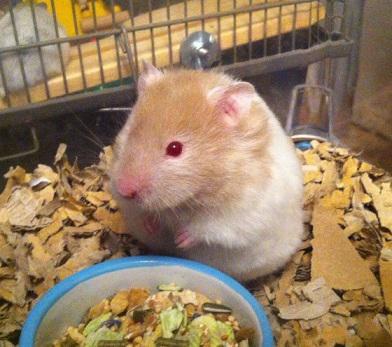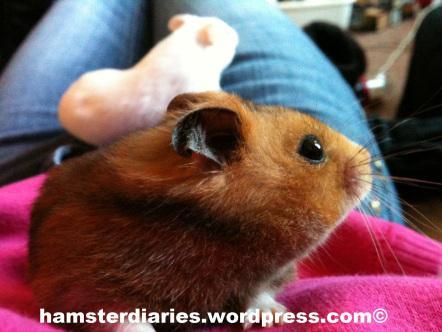The first image is the image on the left, the second image is the image on the right. For the images shown, is this caption "An image contains two hamsters and some part of a human." true? Answer yes or no. Yes. The first image is the image on the left, the second image is the image on the right. Evaluate the accuracy of this statement regarding the images: "A hamster is standing on its hind legs with its front legs up and not touching the ground.". Is it true? Answer yes or no. Yes. 